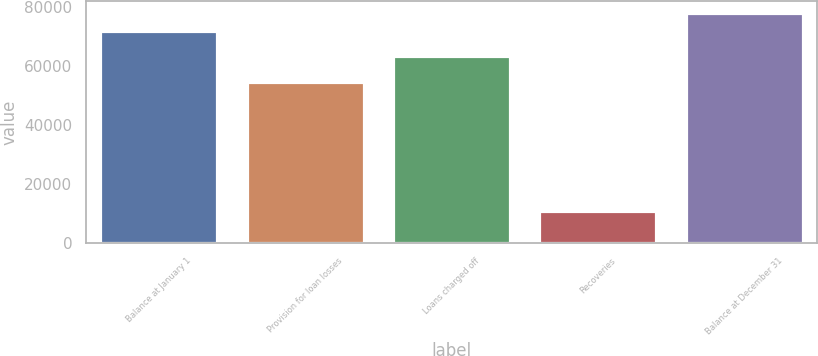Convert chart to OTSL. <chart><loc_0><loc_0><loc_500><loc_500><bar_chart><fcel>Balance at January 1<fcel>Provision for loan losses<fcel>Loans charged off<fcel>Recoveries<fcel>Balance at December 31<nl><fcel>71800<fcel>54602<fcel>63380<fcel>10778<fcel>78102.2<nl></chart> 